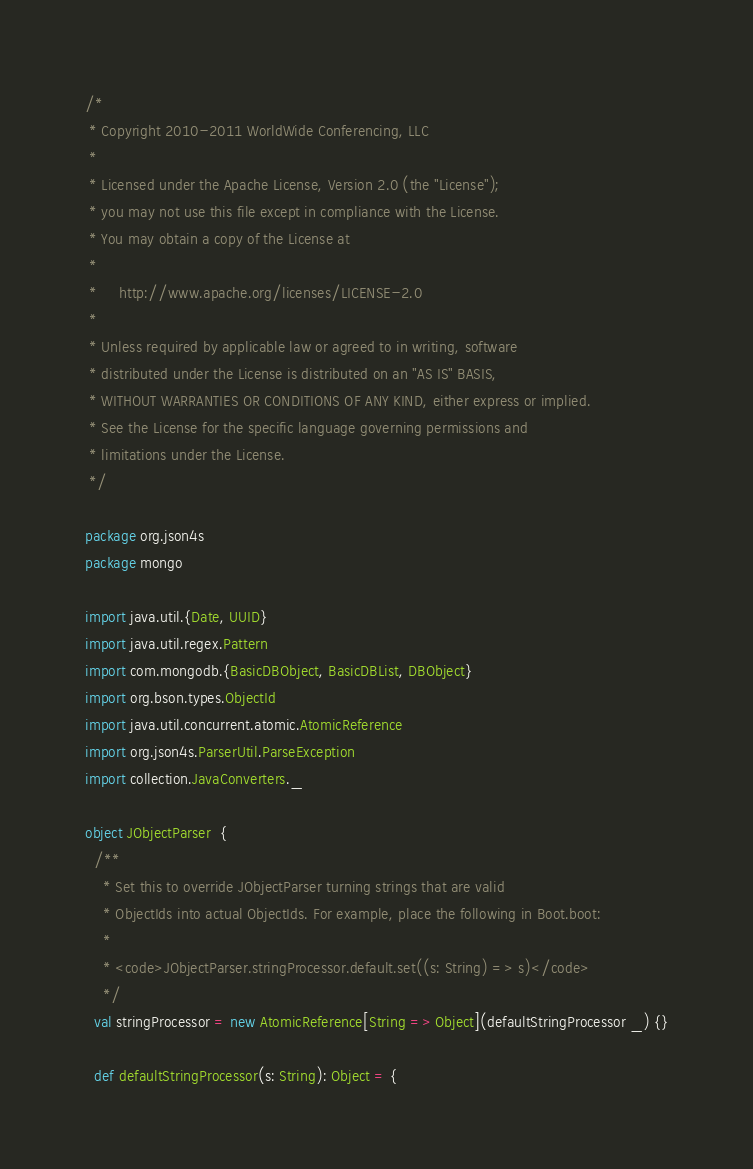Convert code to text. <code><loc_0><loc_0><loc_500><loc_500><_Scala_>/*
 * Copyright 2010-2011 WorldWide Conferencing, LLC
 *
 * Licensed under the Apache License, Version 2.0 (the "License");
 * you may not use this file except in compliance with the License.
 * You may obtain a copy of the License at
 *
 *     http://www.apache.org/licenses/LICENSE-2.0
 *
 * Unless required by applicable law or agreed to in writing, software
 * distributed under the License is distributed on an "AS IS" BASIS,
 * WITHOUT WARRANTIES OR CONDITIONS OF ANY KIND, either express or implied.
 * See the License for the specific language governing permissions and
 * limitations under the License.
 */

package org.json4s
package mongo

import java.util.{Date, UUID}
import java.util.regex.Pattern
import com.mongodb.{BasicDBObject, BasicDBList, DBObject}
import org.bson.types.ObjectId
import java.util.concurrent.atomic.AtomicReference
import org.json4s.ParserUtil.ParseException
import collection.JavaConverters._

object JObjectParser  {
  /**
    * Set this to override JObjectParser turning strings that are valid
    * ObjectIds into actual ObjectIds. For example, place the following in Boot.boot:
    *
    * <code>JObjectParser.stringProcessor.default.set((s: String) => s)</code>
    */
  val stringProcessor = new AtomicReference[String => Object](defaultStringProcessor _) {}

  def defaultStringProcessor(s: String): Object = {</code> 